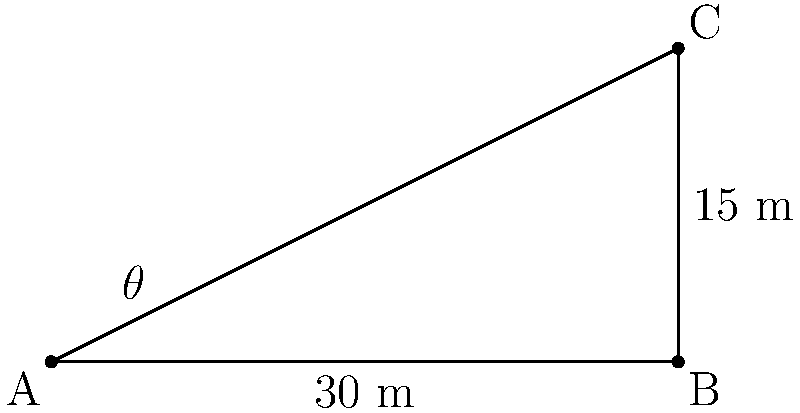As a geologist assessing a mineral vein on a rancher's land, you've measured the horizontal distance from point A to B as 30 meters, and the vertical height from B to C as 15 meters. What is the angle of inclination ($\theta$) of the mineral vein? To find the angle of inclination ($\theta$), we can use the tangent trigonometric ratio. Here's how:

1) In a right triangle, $\tan \theta = \frac{\text{opposite}}{\text{adjacent}}$

2) In this case:
   - The opposite side is the vertical height (BC) = 15 m
   - The adjacent side is the horizontal distance (AB) = 30 m

3) Substituting these values:

   $\tan \theta = \frac{15}{30} = \frac{1}{2} = 0.5$

4) To find $\theta$, we need to use the inverse tangent (arctan or $\tan^{-1}$):

   $\theta = \tan^{-1}(0.5)$

5) Using a calculator or trigonometric tables:

   $\theta \approx 26.57°$

Therefore, the angle of inclination of the mineral vein is approximately 26.57°.
Answer: $26.57°$ 